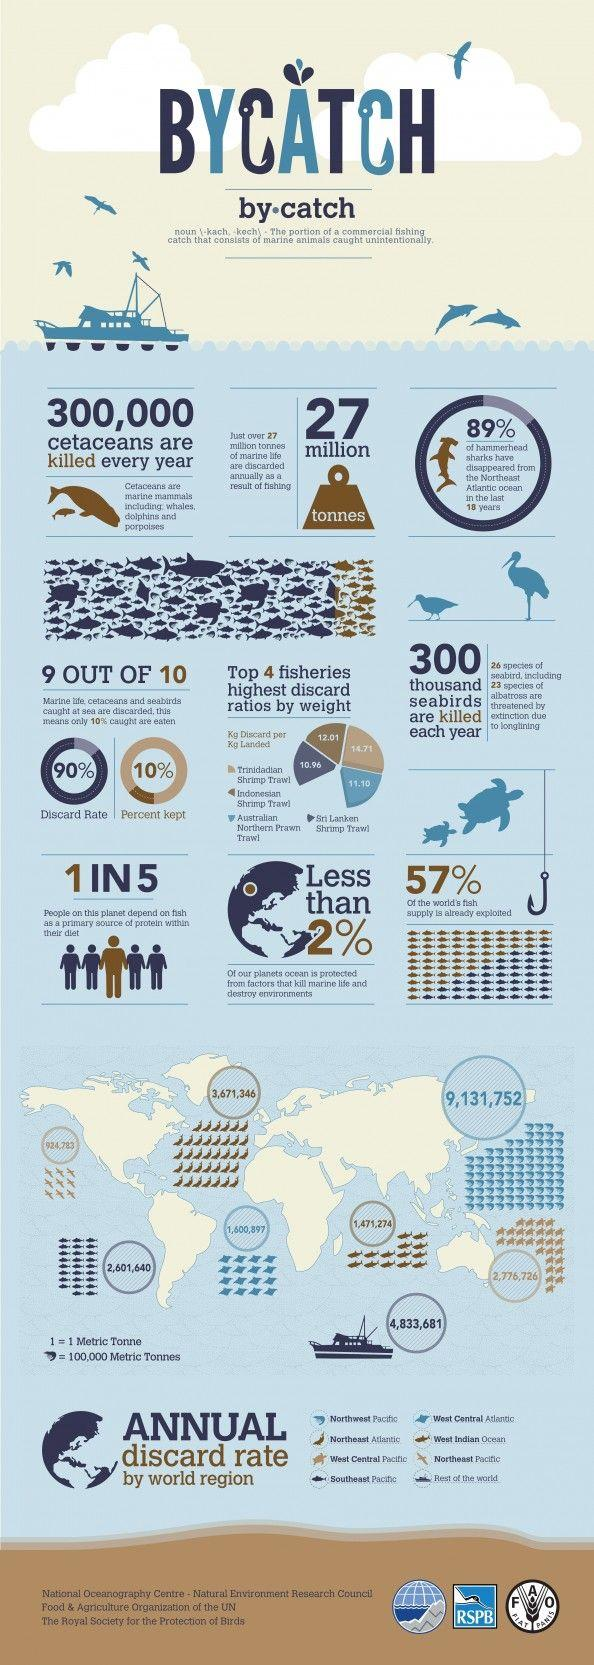Point out several critical features in this image. Approximately 43% of the world's fish supply remains unexploited. 